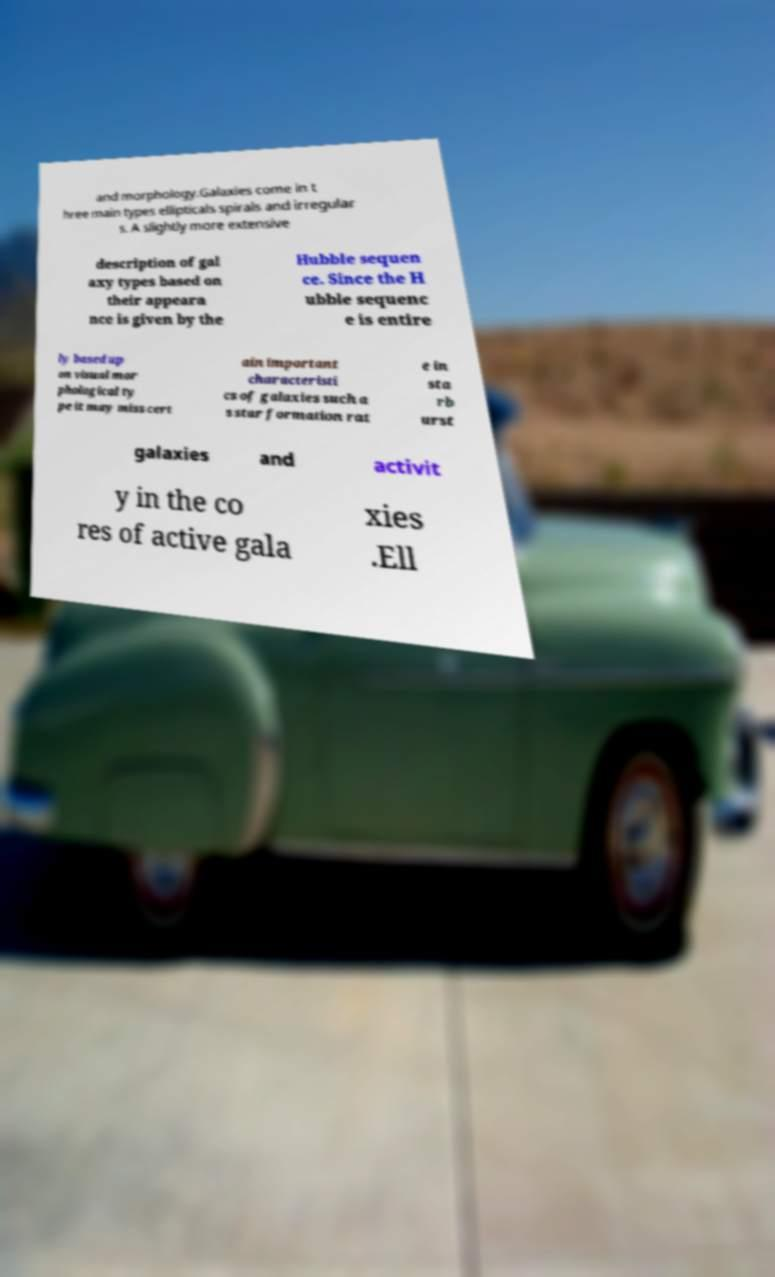For documentation purposes, I need the text within this image transcribed. Could you provide that? and morphology.Galaxies come in t hree main types ellipticals spirals and irregular s. A slightly more extensive description of gal axy types based on their appeara nce is given by the Hubble sequen ce. Since the H ubble sequenc e is entire ly based up on visual mor phological ty pe it may miss cert ain important characteristi cs of galaxies such a s star formation rat e in sta rb urst galaxies and activit y in the co res of active gala xies .Ell 